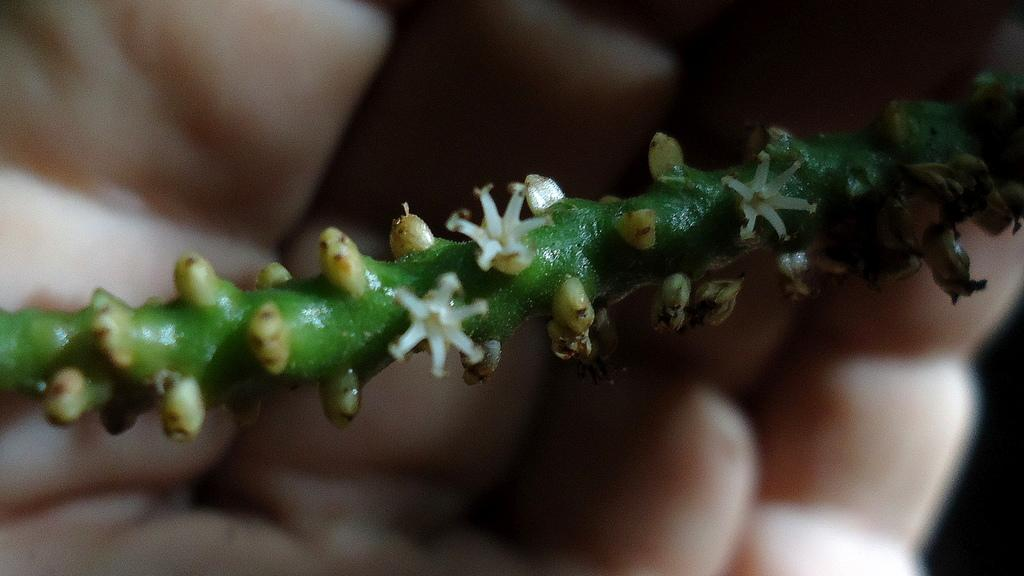What is the color of the stem in the image? The stem in the image is green. How many flowers are attached to the stem? There are 3 flowers on the stem. What is the color of the flowers? The flowers are white in color. Can you describe the background of the image? The background of the image is blurred. How would you describe the lighting in the image? The image appears to be a bit dark. What type of knee injury is visible in the image? There is no knee injury present in the image; it features a green stem with white flowers. Can you tell me which airport is depicted in the image? There is no airport present in the image; it features a green stem with white flowers. 